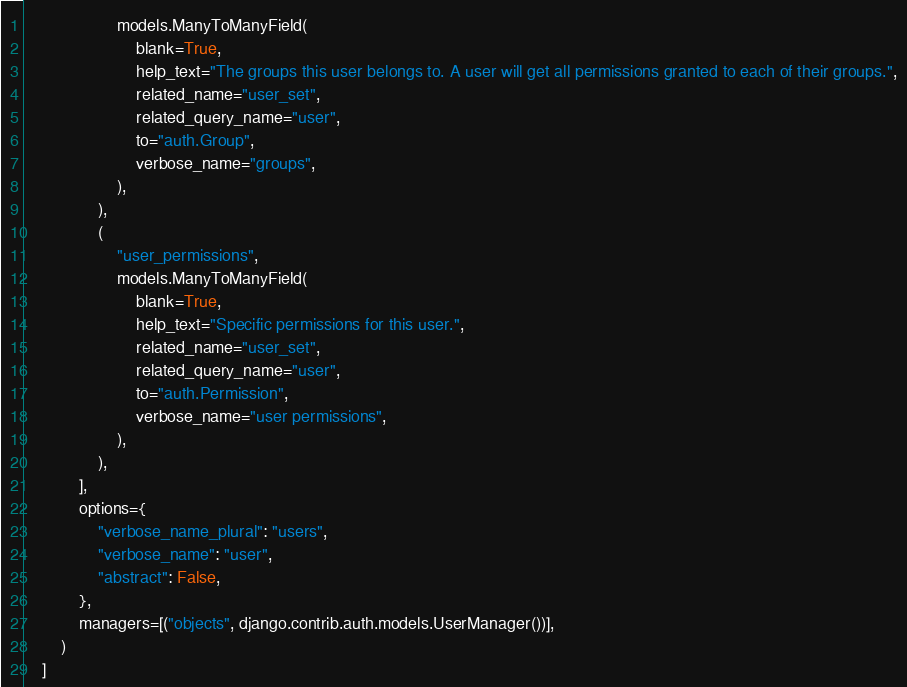Convert code to text. <code><loc_0><loc_0><loc_500><loc_500><_Python_>                    models.ManyToManyField(
                        blank=True,
                        help_text="The groups this user belongs to. A user will get all permissions granted to each of their groups.",
                        related_name="user_set",
                        related_query_name="user",
                        to="auth.Group",
                        verbose_name="groups",
                    ),
                ),
                (
                    "user_permissions",
                    models.ManyToManyField(
                        blank=True,
                        help_text="Specific permissions for this user.",
                        related_name="user_set",
                        related_query_name="user",
                        to="auth.Permission",
                        verbose_name="user permissions",
                    ),
                ),
            ],
            options={
                "verbose_name_plural": "users",
                "verbose_name": "user",
                "abstract": False,
            },
            managers=[("objects", django.contrib.auth.models.UserManager())],
        )
    ]
</code> 